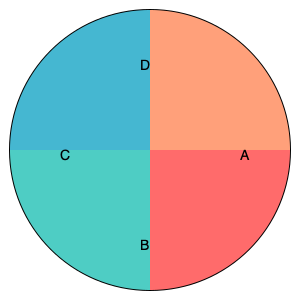As a therapist interested in personality types, you come across a color-coded pie chart representing four different personality categories. If the red section (A) represents "Extroverted Feelers," the green section (B) represents "Introverted Thinkers," and the blue section (C) represents "Introverted Feelers," what personality type is most likely represented by the orange section (D)? To answer this question, we need to analyze the given information and use our understanding of personality types:

1. The chart is divided into four sections, each representing a different personality category.

2. We're given information about three of the four sections:
   A (Red) - Extroverted Feelers
   B (Green) - Introverted Thinkers
   C (Blue) - Introverted Feelers

3. We need to deduce the most likely personality type for section D (Orange).

4. Looking at the pattern, we can observe:
   - There are two introverted types (Thinkers and Feelers)
   - There is one extroverted type (Feelers)

5. To complete the pattern, the missing type would logically be:
   - Extroverted Thinkers

6. This maintains a balance between:
   - Two Extroverted types (Feelers and Thinkers)
   - Two Introverted types (Feelers and Thinkers)
   - Two Feeling types (Extroverted and Introverted)
   - Two Thinking types (Extroverted and Introverted)

Therefore, the most likely personality type represented by the orange section (D) is Extroverted Thinkers.
Answer: Extroverted Thinkers 